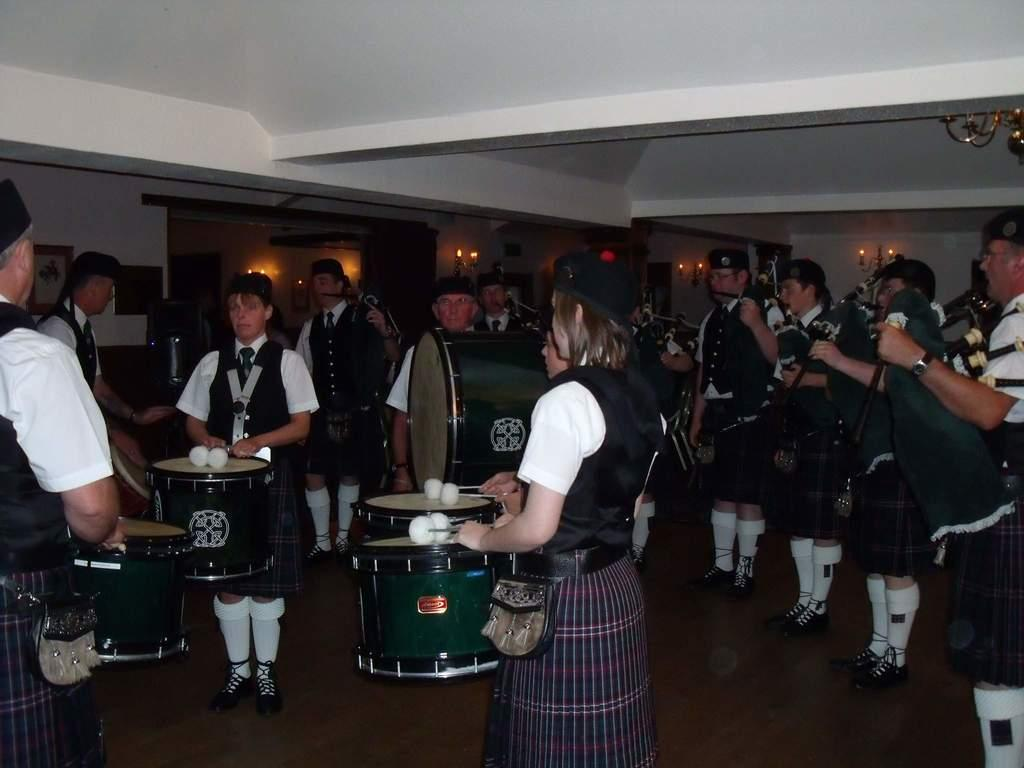How many persons are in the image? There are persons in the image. What are the persons wearing? The persons are wearing white and green dresses. What are the persons doing in the image? The persons are standing and playing musical instruments. What can be seen in the background of the image? There are lights and other objects in the background of the image. Are there any icicles hanging from the musical instruments in the image? There are no icicles present in the image. What type of table is visible in the image? There is no table visible in the image. 